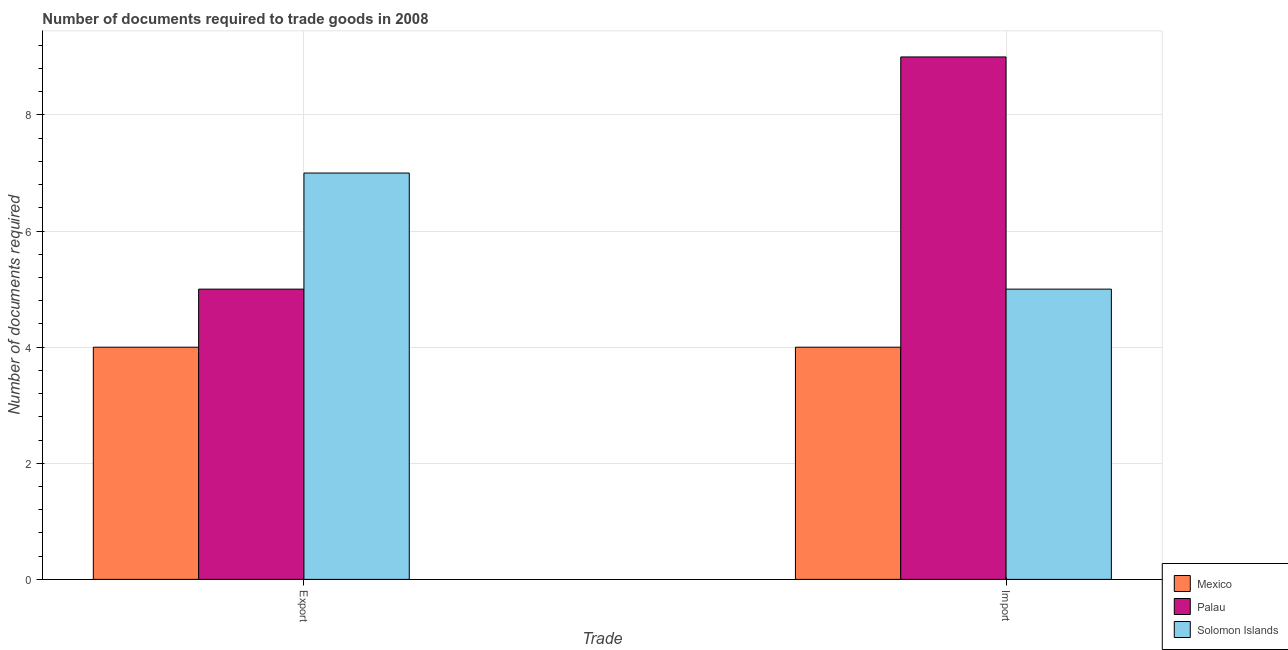How many different coloured bars are there?
Give a very brief answer. 3. How many groups of bars are there?
Keep it short and to the point. 2. Are the number of bars per tick equal to the number of legend labels?
Offer a very short reply. Yes. Are the number of bars on each tick of the X-axis equal?
Keep it short and to the point. Yes. How many bars are there on the 2nd tick from the left?
Provide a short and direct response. 3. How many bars are there on the 2nd tick from the right?
Offer a terse response. 3. What is the label of the 2nd group of bars from the left?
Your answer should be very brief. Import. What is the number of documents required to export goods in Palau?
Your answer should be compact. 5. Across all countries, what is the maximum number of documents required to export goods?
Give a very brief answer. 7. Across all countries, what is the minimum number of documents required to import goods?
Provide a succinct answer. 4. In which country was the number of documents required to import goods maximum?
Your answer should be compact. Palau. What is the total number of documents required to import goods in the graph?
Offer a terse response. 18. What is the difference between the number of documents required to export goods in Mexico and that in Solomon Islands?
Give a very brief answer. -3. What is the difference between the number of documents required to import goods in Solomon Islands and the number of documents required to export goods in Palau?
Make the answer very short. 0. What is the average number of documents required to export goods per country?
Your response must be concise. 5.33. What is the difference between the number of documents required to import goods and number of documents required to export goods in Solomon Islands?
Ensure brevity in your answer.  -2. What is the ratio of the number of documents required to export goods in Palau to that in Solomon Islands?
Offer a terse response. 0.71. Is the number of documents required to export goods in Palau less than that in Mexico?
Keep it short and to the point. No. What does the 2nd bar from the left in Export represents?
Your answer should be very brief. Palau. What does the 1st bar from the right in Import represents?
Offer a very short reply. Solomon Islands. How many bars are there?
Your response must be concise. 6. How many countries are there in the graph?
Provide a succinct answer. 3. Are the values on the major ticks of Y-axis written in scientific E-notation?
Your response must be concise. No. How are the legend labels stacked?
Make the answer very short. Vertical. What is the title of the graph?
Give a very brief answer. Number of documents required to trade goods in 2008. What is the label or title of the X-axis?
Your answer should be compact. Trade. What is the label or title of the Y-axis?
Your answer should be very brief. Number of documents required. What is the Number of documents required in Mexico in Export?
Provide a short and direct response. 4. What is the Number of documents required in Palau in Export?
Give a very brief answer. 5. Across all Trade, what is the maximum Number of documents required of Mexico?
Make the answer very short. 4. Across all Trade, what is the maximum Number of documents required of Solomon Islands?
Make the answer very short. 7. Across all Trade, what is the minimum Number of documents required of Mexico?
Your response must be concise. 4. Across all Trade, what is the minimum Number of documents required of Palau?
Provide a short and direct response. 5. Across all Trade, what is the minimum Number of documents required of Solomon Islands?
Offer a very short reply. 5. What is the total Number of documents required of Mexico in the graph?
Offer a very short reply. 8. What is the total Number of documents required of Palau in the graph?
Your answer should be very brief. 14. What is the total Number of documents required in Solomon Islands in the graph?
Your answer should be very brief. 12. What is the difference between the Number of documents required in Mexico in Export and that in Import?
Offer a very short reply. 0. What is the difference between the Number of documents required in Mexico in Export and the Number of documents required in Palau in Import?
Offer a terse response. -5. What is the difference between the Number of documents required of Mexico in Export and the Number of documents required of Solomon Islands in Import?
Provide a short and direct response. -1. What is the difference between the Number of documents required in Palau in Export and the Number of documents required in Solomon Islands in Import?
Offer a terse response. 0. What is the average Number of documents required of Mexico per Trade?
Your answer should be very brief. 4. What is the average Number of documents required of Solomon Islands per Trade?
Make the answer very short. 6. What is the difference between the Number of documents required in Mexico and Number of documents required in Palau in Export?
Offer a terse response. -1. What is the difference between the Number of documents required in Palau and Number of documents required in Solomon Islands in Export?
Keep it short and to the point. -2. What is the difference between the Number of documents required of Mexico and Number of documents required of Palau in Import?
Make the answer very short. -5. What is the difference between the Number of documents required in Palau and Number of documents required in Solomon Islands in Import?
Make the answer very short. 4. What is the ratio of the Number of documents required of Mexico in Export to that in Import?
Keep it short and to the point. 1. What is the ratio of the Number of documents required in Palau in Export to that in Import?
Make the answer very short. 0.56. What is the difference between the highest and the second highest Number of documents required in Mexico?
Offer a terse response. 0. What is the difference between the highest and the second highest Number of documents required in Palau?
Your answer should be compact. 4. What is the difference between the highest and the lowest Number of documents required of Solomon Islands?
Provide a succinct answer. 2. 